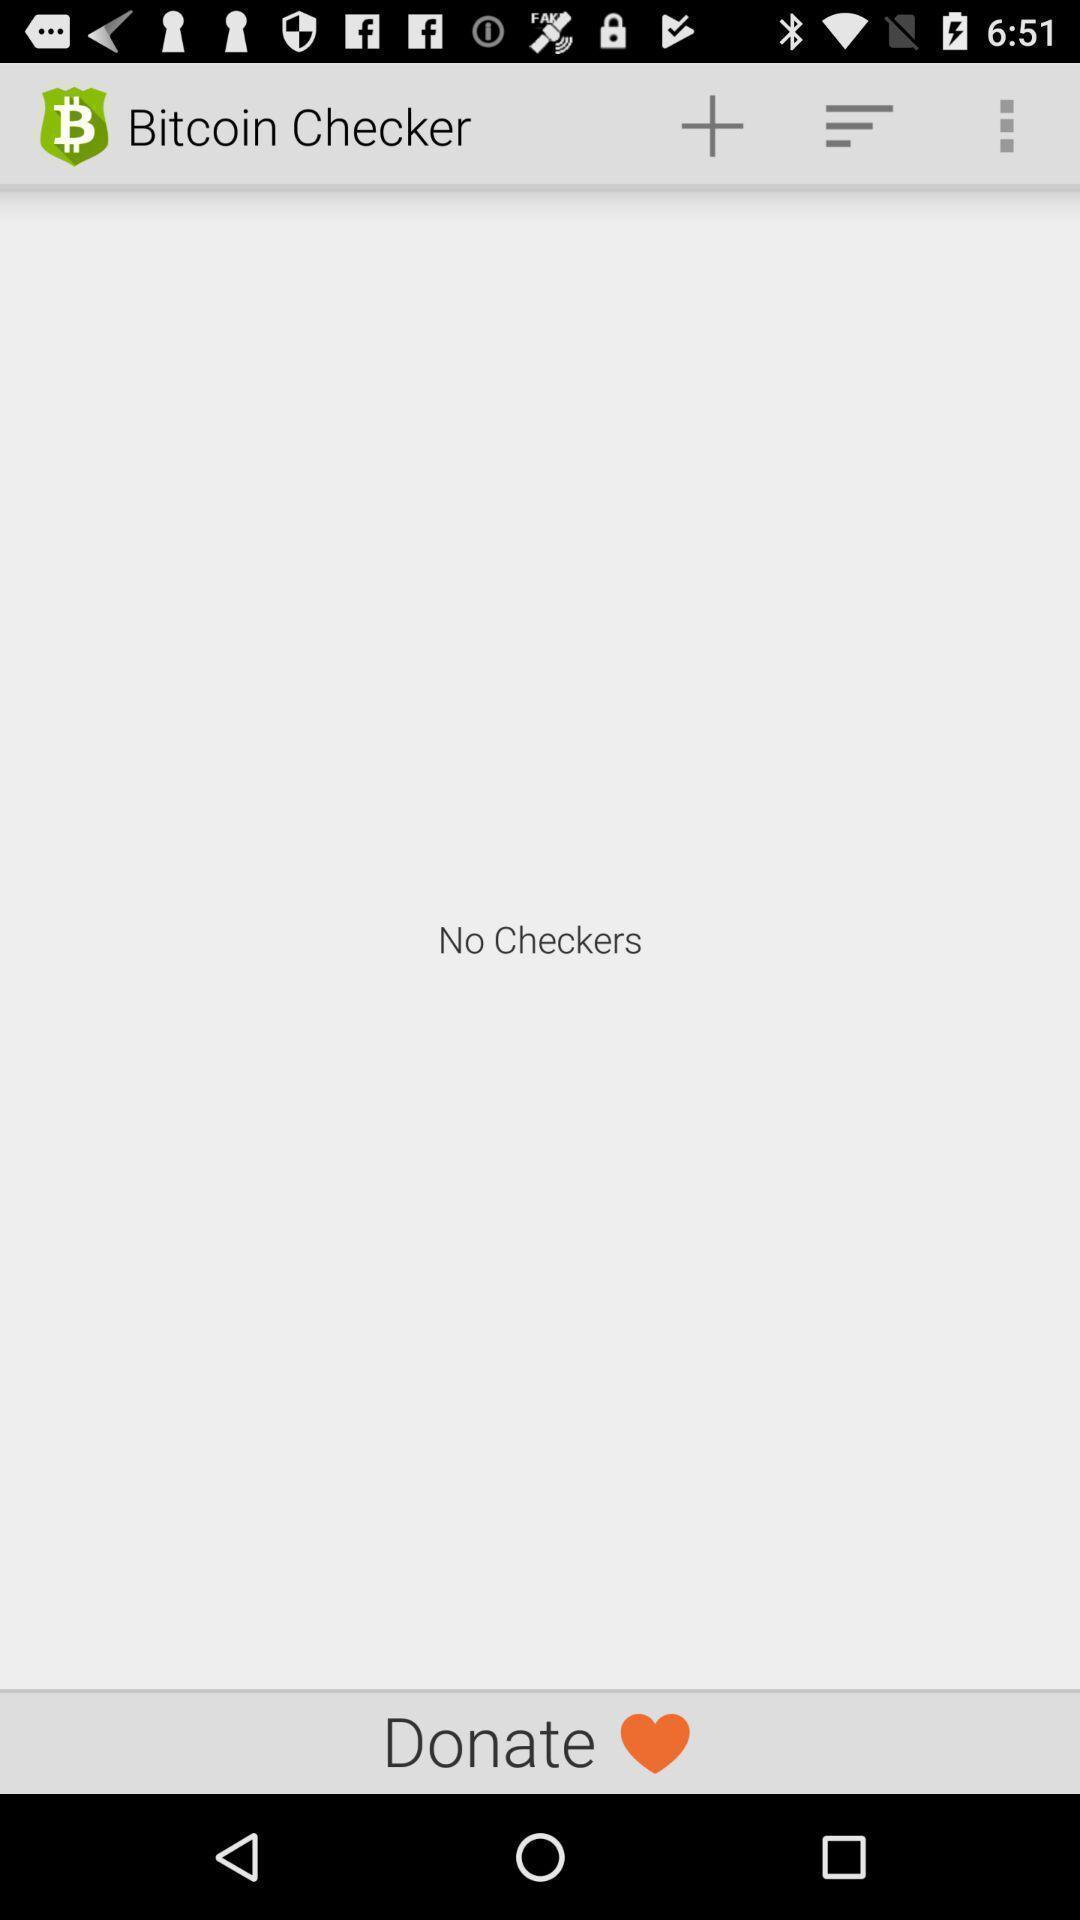Explain the elements present in this screenshot. Screen displaying multiple control options. 